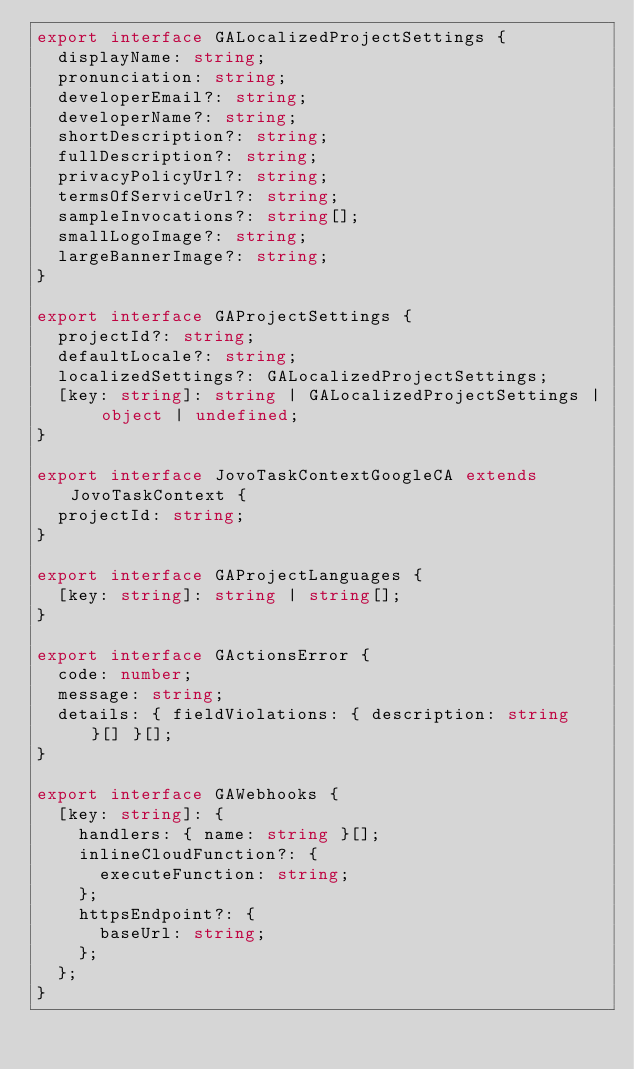Convert code to text. <code><loc_0><loc_0><loc_500><loc_500><_TypeScript_>export interface GALocalizedProjectSettings {
  displayName: string;
  pronunciation: string;
  developerEmail?: string;
  developerName?: string;
  shortDescription?: string;
  fullDescription?: string;
  privacyPolicyUrl?: string;
  termsOfServiceUrl?: string;
  sampleInvocations?: string[];
  smallLogoImage?: string;
  largeBannerImage?: string;
}

export interface GAProjectSettings {
  projectId?: string;
  defaultLocale?: string;
  localizedSettings?: GALocalizedProjectSettings;
  [key: string]: string | GALocalizedProjectSettings | object | undefined;
}

export interface JovoTaskContextGoogleCA extends JovoTaskContext {
  projectId: string;
}

export interface GAProjectLanguages {
  [key: string]: string | string[];
}

export interface GActionsError {
  code: number;
  message: string;
  details: { fieldViolations: { description: string }[] }[];
}

export interface GAWebhooks {
  [key: string]: {
    handlers: { name: string }[];
    inlineCloudFunction?: {
      executeFunction: string;
    };
    httpsEndpoint?: {
      baseUrl: string;
    };
  };
}
</code> 